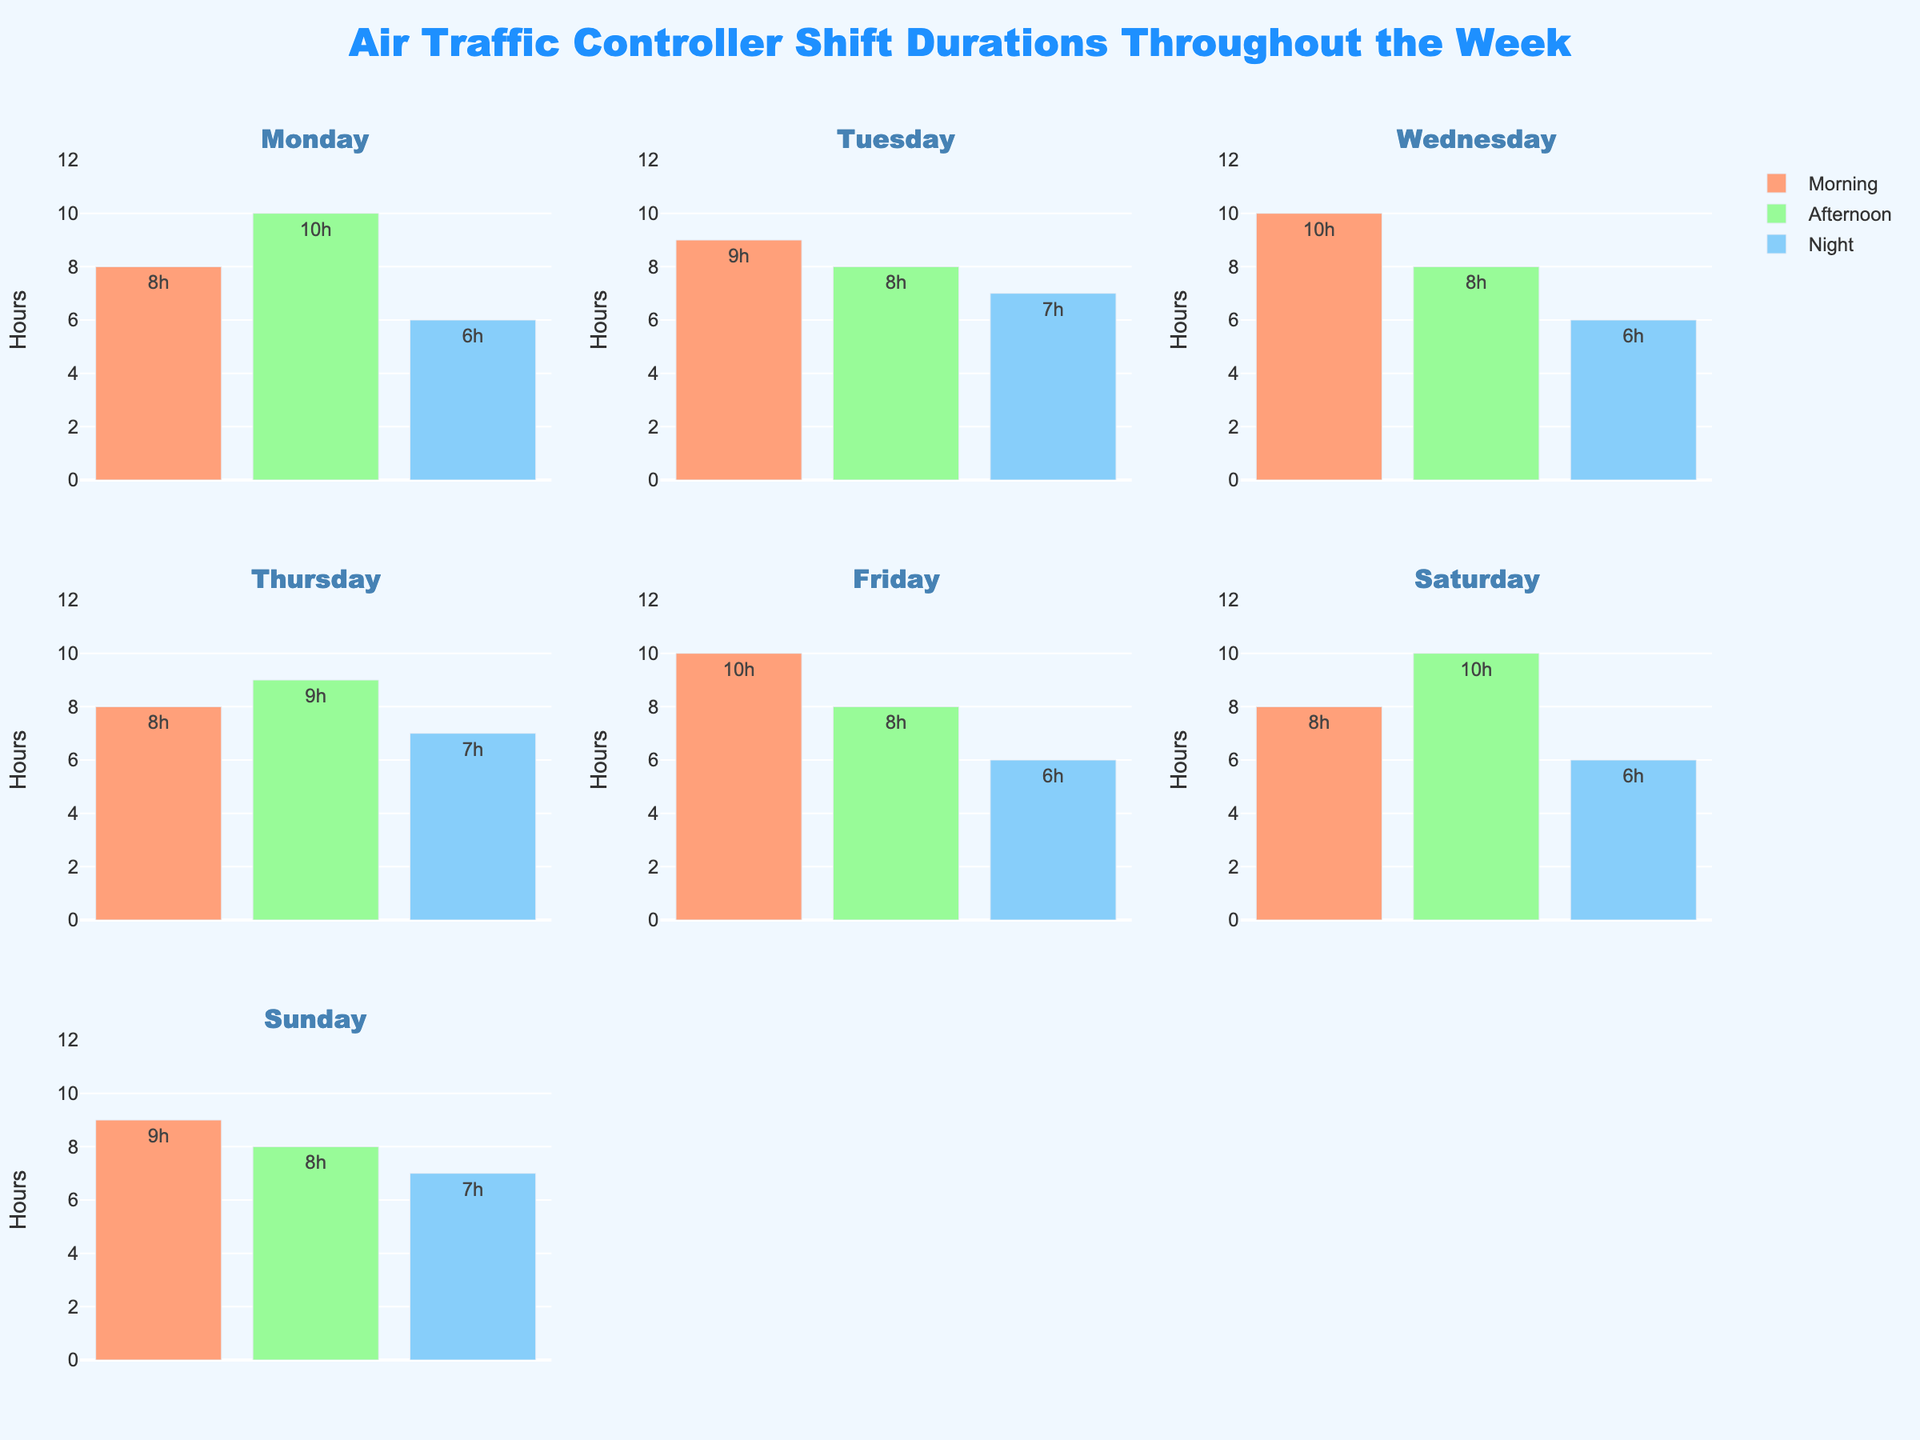What is the title of the entire figure? The title is located at the top of the figure, and it provides a summary of what is being displayed.
Answer: Air Traffic Controller Shift Durations Throughout the Week Which day has the longest morning shift? Look at the morning shift bars across all subplots. Identify the tallest bar, which represents the longest shift duration.
Answer: Wednesday and Friday What is the total shift duration on Monday? Add up the duration hours of all shifts (morning, afternoon, and night) for Monday. Morning: 8, Afternoon: 10, Night: 6. So, 8 + 10 + 6 = 24
Answer: 24 hours Which shift color represents the afternoon shift? Colors are consistently used to represent shifts across all subplots. Look for the color bar that appears in the middle of each subplot.
Answer: Green Which day has the shortest night shift? Examine the night shift bars across all subplots and find the shortest one. The shorter the bar, the fewer the hours.
Answer: Multiple days (Monday, Wednesday, Friday, Saturday) with 6 hours Compare the duration of the night shift on Tuesday and Thursday. Which one is longer? Look at the bar representing the night shift for Tuesday and Thursday. Compare the lengths of these bars.
Answer: They are the same On which day is the afternoon shift duration the highest? Identify the tallest green bar across all days, which represents the afternoon shift duration.
Answer: Monday and Saturday How does the average shift duration on Sunday compare to the other days? Calculate the average shift duration for Sunday by summing the duration of all shifts and dividing by 3, then compare with other days in a similar manner.
Answer: 8 hours for every day What is the difference in duration between the longest and shortest shifts throughout the entire week? Identify the longest shift (tallest bar) and the shortest shift (shortest bar) in all subplots. Subtract the shortest duration from the longest one.
Answer: 4 hours (10 hours longest - 6 hours shortest) Which shift is represented by a blue color across the figure? Identify the shift represented by the blue bar by looking at the color key or legend.
Answer: Night 